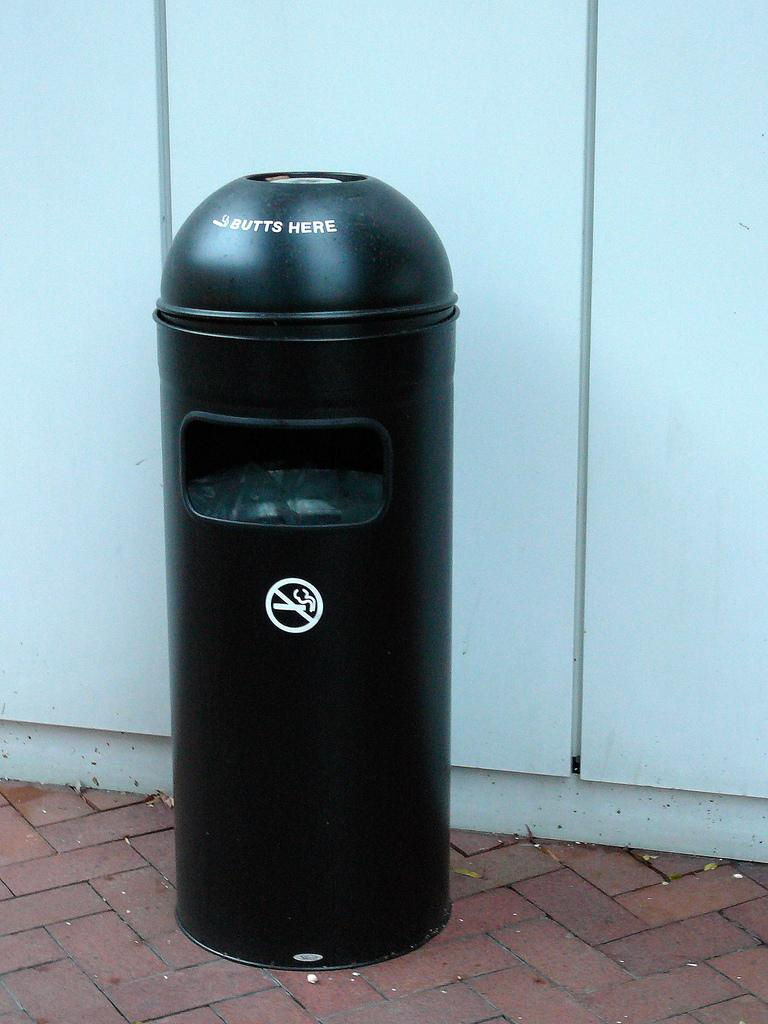<image>
Summarize the visual content of the image. A black trash can with the sign on it that says "butts here" 